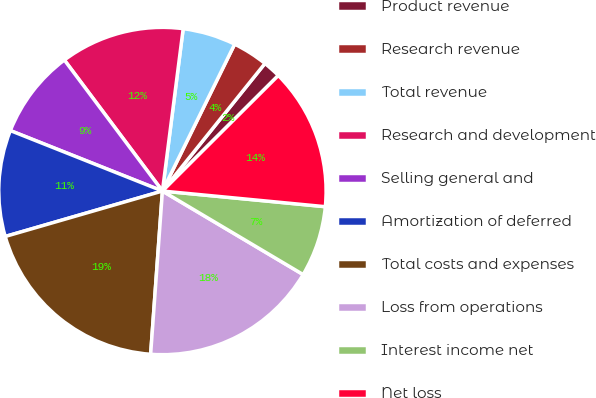Convert chart. <chart><loc_0><loc_0><loc_500><loc_500><pie_chart><fcel>Product revenue<fcel>Research revenue<fcel>Total revenue<fcel>Research and development<fcel>Selling general and<fcel>Amortization of deferred<fcel>Total costs and expenses<fcel>Loss from operations<fcel>Interest income net<fcel>Net loss<nl><fcel>1.75%<fcel>3.5%<fcel>5.25%<fcel>12.25%<fcel>8.75%<fcel>10.5%<fcel>19.37%<fcel>17.62%<fcel>7.0%<fcel>14.0%<nl></chart> 